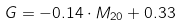<formula> <loc_0><loc_0><loc_500><loc_500>G = - 0 . 1 4 \cdot M _ { 2 0 } + 0 . 3 3</formula> 